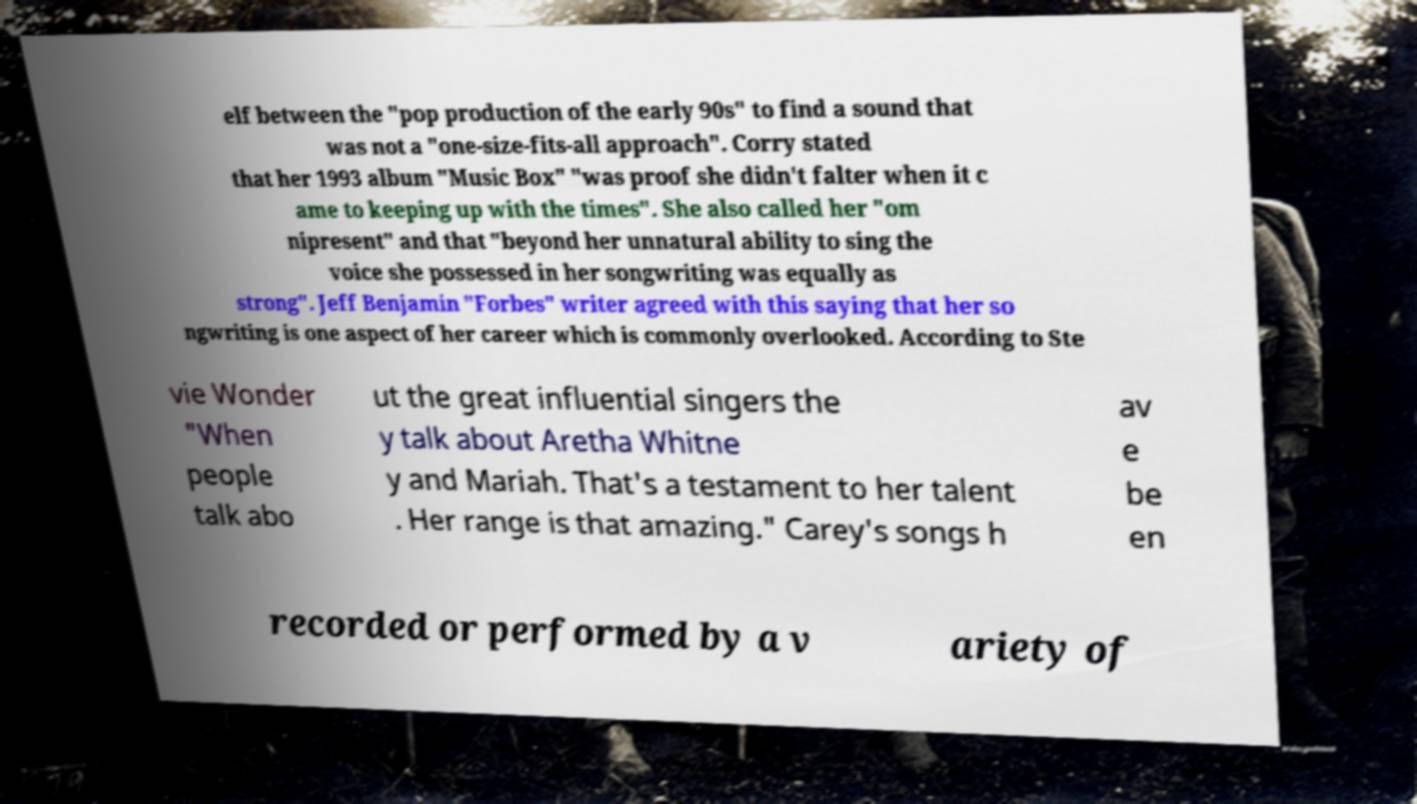What messages or text are displayed in this image? I need them in a readable, typed format. elf between the "pop production of the early 90s" to find a sound that was not a "one-size-fits-all approach". Corry stated that her 1993 album "Music Box" "was proof she didn't falter when it c ame to keeping up with the times". She also called her "om nipresent" and that "beyond her unnatural ability to sing the voice she possessed in her songwriting was equally as strong". Jeff Benjamin "Forbes" writer agreed with this saying that her so ngwriting is one aspect of her career which is commonly overlooked. According to Ste vie Wonder "When people talk abo ut the great influential singers the y talk about Aretha Whitne y and Mariah. That's a testament to her talent . Her range is that amazing." Carey's songs h av e be en recorded or performed by a v ariety of 